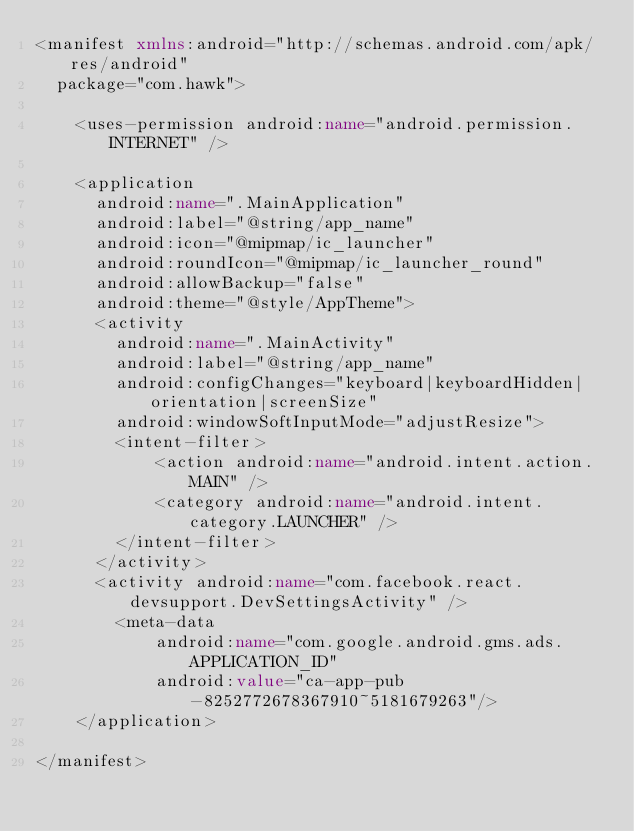<code> <loc_0><loc_0><loc_500><loc_500><_XML_><manifest xmlns:android="http://schemas.android.com/apk/res/android"
  package="com.hawk">

    <uses-permission android:name="android.permission.INTERNET" />

    <application
      android:name=".MainApplication"
      android:label="@string/app_name"
      android:icon="@mipmap/ic_launcher"
      android:roundIcon="@mipmap/ic_launcher_round"
      android:allowBackup="false"
      android:theme="@style/AppTheme">
      <activity
        android:name=".MainActivity"
        android:label="@string/app_name"
        android:configChanges="keyboard|keyboardHidden|orientation|screenSize"
        android:windowSoftInputMode="adjustResize">
        <intent-filter>
            <action android:name="android.intent.action.MAIN" />
            <category android:name="android.intent.category.LAUNCHER" />
        </intent-filter>
      </activity>
      <activity android:name="com.facebook.react.devsupport.DevSettingsActivity" />
        <meta-data
            android:name="com.google.android.gms.ads.APPLICATION_ID"
            android:value="ca-app-pub-8252772678367910~5181679263"/>
    </application>

</manifest>
</code> 